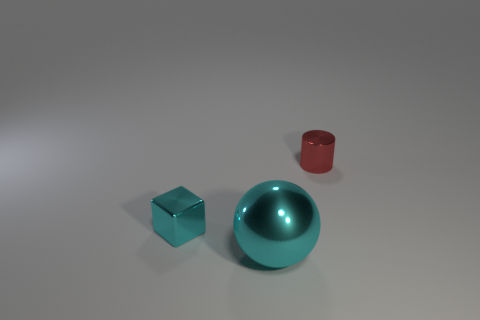Are there any other things that have the same color as the big metal thing?
Ensure brevity in your answer.  Yes. What is the size of the metallic sphere that is the same color as the metallic block?
Your answer should be very brief. Large. What is the material of the tiny cube that is the same color as the big thing?
Offer a very short reply. Metal. Is there a metallic thing of the same color as the ball?
Ensure brevity in your answer.  Yes. How big is the cyan shiny object that is in front of the tiny cyan block?
Your answer should be compact. Large. Is there a large brown thing that has the same material as the big sphere?
Keep it short and to the point. No. There is a cyan object behind the shiny sphere that is right of the tiny shiny thing on the left side of the small metallic cylinder; what is its shape?
Give a very brief answer. Cube. What is the material of the thing that is both behind the large shiny ball and left of the red thing?
Your answer should be very brief. Metal. There is a cyan object right of the cyan metallic block; is it the same size as the small red cylinder?
Keep it short and to the point. No. Is there anything else that has the same size as the cyan sphere?
Make the answer very short. No. 